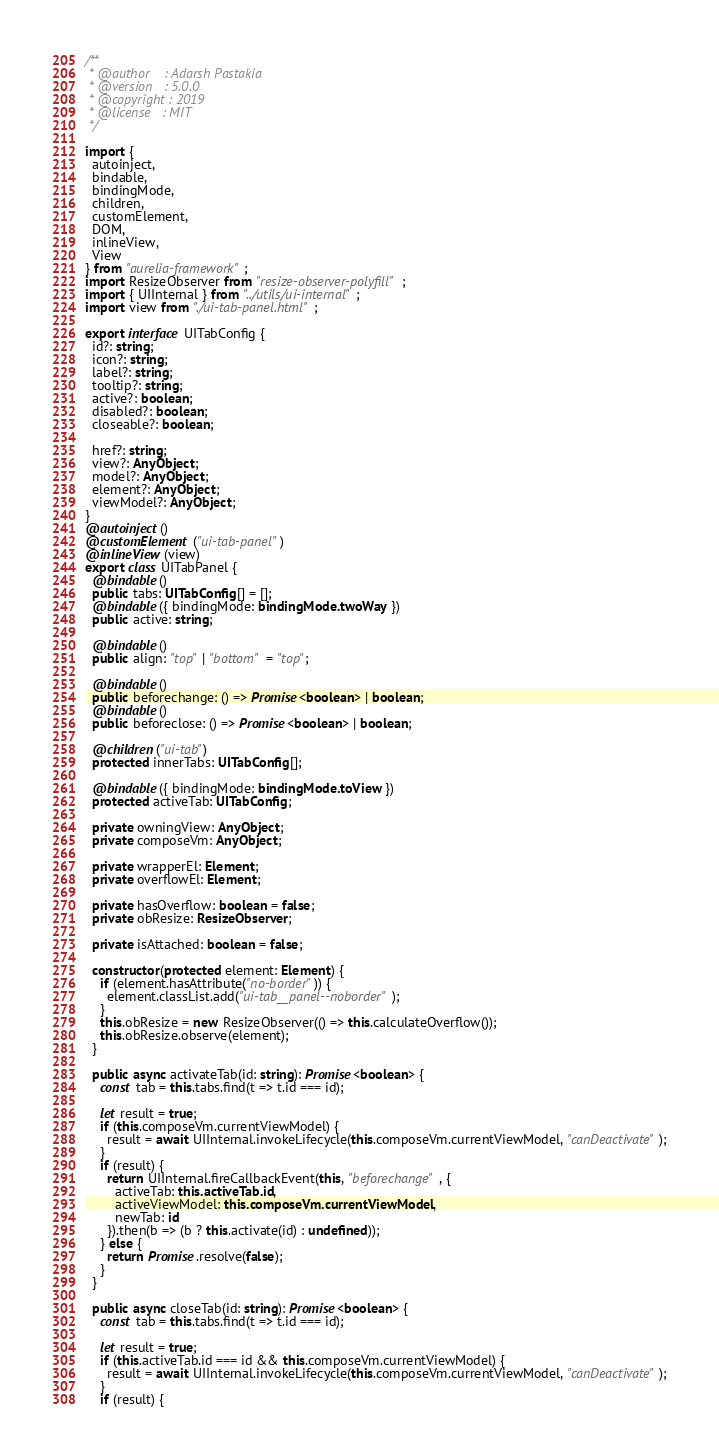Convert code to text. <code><loc_0><loc_0><loc_500><loc_500><_TypeScript_>/**
 * @author    : Adarsh Pastakia
 * @version   : 5.0.0
 * @copyright : 2019
 * @license   : MIT
 */

import {
  autoinject,
  bindable,
  bindingMode,
  children,
  customElement,
  DOM,
  inlineView,
  View
} from "aurelia-framework";
import ResizeObserver from "resize-observer-polyfill";
import { UIInternal } from "../utils/ui-internal";
import view from "./ui-tab-panel.html";

export interface UITabConfig {
  id?: string;
  icon?: string;
  label?: string;
  tooltip?: string;
  active?: boolean;
  disabled?: boolean;
  closeable?: boolean;

  href?: string;
  view?: AnyObject;
  model?: AnyObject;
  element?: AnyObject;
  viewModel?: AnyObject;
}
@autoinject()
@customElement("ui-tab-panel")
@inlineView(view)
export class UITabPanel {
  @bindable()
  public tabs: UITabConfig[] = [];
  @bindable({ bindingMode: bindingMode.twoWay })
  public active: string;

  @bindable()
  public align: "top" | "bottom" = "top";

  @bindable()
  public beforechange: () => Promise<boolean> | boolean;
  @bindable()
  public beforeclose: () => Promise<boolean> | boolean;

  @children("ui-tab")
  protected innerTabs: UITabConfig[];

  @bindable({ bindingMode: bindingMode.toView })
  protected activeTab: UITabConfig;

  private owningView: AnyObject;
  private composeVm: AnyObject;

  private wrapperEl: Element;
  private overflowEl: Element;

  private hasOverflow: boolean = false;
  private obResize: ResizeObserver;

  private isAttached: boolean = false;

  constructor(protected element: Element) {
    if (element.hasAttribute("no-border")) {
      element.classList.add("ui-tab__panel--noborder");
    }
    this.obResize = new ResizeObserver(() => this.calculateOverflow());
    this.obResize.observe(element);
  }

  public async activateTab(id: string): Promise<boolean> {
    const tab = this.tabs.find(t => t.id === id);

    let result = true;
    if (this.composeVm.currentViewModel) {
      result = await UIInternal.invokeLifecycle(this.composeVm.currentViewModel, "canDeactivate");
    }
    if (result) {
      return UIInternal.fireCallbackEvent(this, "beforechange", {
        activeTab: this.activeTab.id,
        activeViewModel: this.composeVm.currentViewModel,
        newTab: id
      }).then(b => (b ? this.activate(id) : undefined));
    } else {
      return Promise.resolve(false);
    }
  }

  public async closeTab(id: string): Promise<boolean> {
    const tab = this.tabs.find(t => t.id === id);

    let result = true;
    if (this.activeTab.id === id && this.composeVm.currentViewModel) {
      result = await UIInternal.invokeLifecycle(this.composeVm.currentViewModel, "canDeactivate");
    }
    if (result) {</code> 